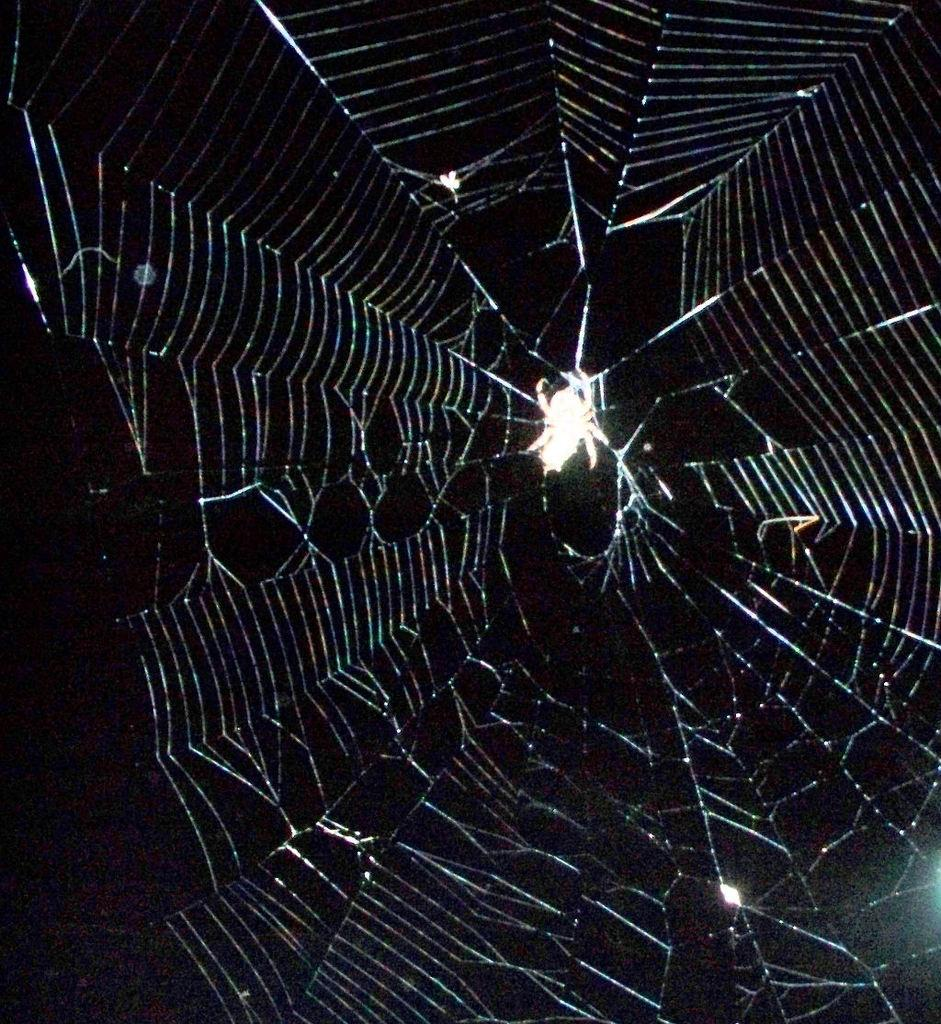What is present in the image? There is a spider web in the image. What can be observed about the background of the image? The background of the image is dark. What type of laborer can be seen working in the steel industry in the image? There is no laborer or steel industry present in the image; it only features a spider web and a dark background. 